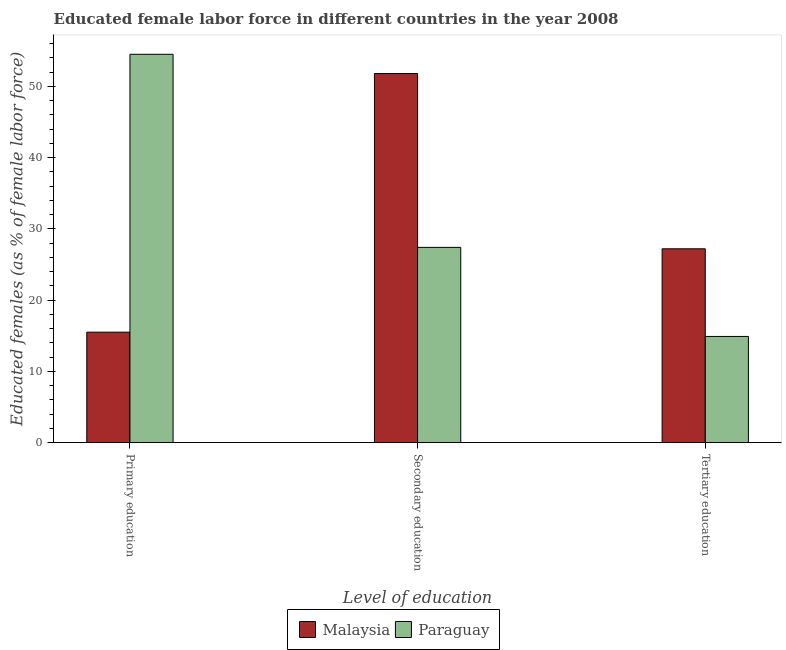How many groups of bars are there?
Your answer should be very brief. 3. Are the number of bars on each tick of the X-axis equal?
Provide a succinct answer. Yes. How many bars are there on the 2nd tick from the left?
Make the answer very short. 2. What is the percentage of female labor force who received tertiary education in Paraguay?
Your answer should be very brief. 14.9. Across all countries, what is the maximum percentage of female labor force who received secondary education?
Your answer should be compact. 51.8. Across all countries, what is the minimum percentage of female labor force who received secondary education?
Provide a succinct answer. 27.4. In which country was the percentage of female labor force who received tertiary education maximum?
Ensure brevity in your answer.  Malaysia. In which country was the percentage of female labor force who received primary education minimum?
Your response must be concise. Malaysia. What is the total percentage of female labor force who received secondary education in the graph?
Your answer should be compact. 79.2. What is the difference between the percentage of female labor force who received primary education in Paraguay and that in Malaysia?
Make the answer very short. 39. What is the difference between the percentage of female labor force who received primary education in Malaysia and the percentage of female labor force who received tertiary education in Paraguay?
Give a very brief answer. 0.6. What is the average percentage of female labor force who received primary education per country?
Your answer should be compact. 35. What is the difference between the percentage of female labor force who received secondary education and percentage of female labor force who received tertiary education in Malaysia?
Offer a very short reply. 24.6. What is the ratio of the percentage of female labor force who received tertiary education in Malaysia to that in Paraguay?
Your answer should be compact. 1.83. What is the difference between the highest and the second highest percentage of female labor force who received tertiary education?
Your response must be concise. 12.3. What is the difference between the highest and the lowest percentage of female labor force who received secondary education?
Offer a terse response. 24.4. Is the sum of the percentage of female labor force who received secondary education in Malaysia and Paraguay greater than the maximum percentage of female labor force who received tertiary education across all countries?
Ensure brevity in your answer.  Yes. What does the 2nd bar from the left in Secondary education represents?
Offer a very short reply. Paraguay. What does the 1st bar from the right in Tertiary education represents?
Offer a very short reply. Paraguay. Are all the bars in the graph horizontal?
Offer a terse response. No. Are the values on the major ticks of Y-axis written in scientific E-notation?
Your answer should be compact. No. How many legend labels are there?
Your answer should be very brief. 2. How are the legend labels stacked?
Keep it short and to the point. Horizontal. What is the title of the graph?
Keep it short and to the point. Educated female labor force in different countries in the year 2008. What is the label or title of the X-axis?
Offer a very short reply. Level of education. What is the label or title of the Y-axis?
Offer a very short reply. Educated females (as % of female labor force). What is the Educated females (as % of female labor force) in Paraguay in Primary education?
Your answer should be compact. 54.5. What is the Educated females (as % of female labor force) of Malaysia in Secondary education?
Make the answer very short. 51.8. What is the Educated females (as % of female labor force) of Paraguay in Secondary education?
Your answer should be very brief. 27.4. What is the Educated females (as % of female labor force) in Malaysia in Tertiary education?
Provide a succinct answer. 27.2. What is the Educated females (as % of female labor force) of Paraguay in Tertiary education?
Your answer should be compact. 14.9. Across all Level of education, what is the maximum Educated females (as % of female labor force) of Malaysia?
Your answer should be compact. 51.8. Across all Level of education, what is the maximum Educated females (as % of female labor force) of Paraguay?
Offer a terse response. 54.5. Across all Level of education, what is the minimum Educated females (as % of female labor force) in Paraguay?
Provide a succinct answer. 14.9. What is the total Educated females (as % of female labor force) in Malaysia in the graph?
Your answer should be very brief. 94.5. What is the total Educated females (as % of female labor force) of Paraguay in the graph?
Keep it short and to the point. 96.8. What is the difference between the Educated females (as % of female labor force) in Malaysia in Primary education and that in Secondary education?
Provide a short and direct response. -36.3. What is the difference between the Educated females (as % of female labor force) in Paraguay in Primary education and that in Secondary education?
Your response must be concise. 27.1. What is the difference between the Educated females (as % of female labor force) of Paraguay in Primary education and that in Tertiary education?
Ensure brevity in your answer.  39.6. What is the difference between the Educated females (as % of female labor force) of Malaysia in Secondary education and that in Tertiary education?
Your answer should be very brief. 24.6. What is the difference between the Educated females (as % of female labor force) in Paraguay in Secondary education and that in Tertiary education?
Give a very brief answer. 12.5. What is the difference between the Educated females (as % of female labor force) in Malaysia in Primary education and the Educated females (as % of female labor force) in Paraguay in Tertiary education?
Offer a terse response. 0.6. What is the difference between the Educated females (as % of female labor force) of Malaysia in Secondary education and the Educated females (as % of female labor force) of Paraguay in Tertiary education?
Your response must be concise. 36.9. What is the average Educated females (as % of female labor force) in Malaysia per Level of education?
Give a very brief answer. 31.5. What is the average Educated females (as % of female labor force) of Paraguay per Level of education?
Make the answer very short. 32.27. What is the difference between the Educated females (as % of female labor force) of Malaysia and Educated females (as % of female labor force) of Paraguay in Primary education?
Your answer should be very brief. -39. What is the difference between the Educated females (as % of female labor force) in Malaysia and Educated females (as % of female labor force) in Paraguay in Secondary education?
Offer a terse response. 24.4. What is the ratio of the Educated females (as % of female labor force) of Malaysia in Primary education to that in Secondary education?
Give a very brief answer. 0.3. What is the ratio of the Educated females (as % of female labor force) in Paraguay in Primary education to that in Secondary education?
Provide a succinct answer. 1.99. What is the ratio of the Educated females (as % of female labor force) in Malaysia in Primary education to that in Tertiary education?
Offer a very short reply. 0.57. What is the ratio of the Educated females (as % of female labor force) of Paraguay in Primary education to that in Tertiary education?
Your answer should be very brief. 3.66. What is the ratio of the Educated females (as % of female labor force) in Malaysia in Secondary education to that in Tertiary education?
Provide a succinct answer. 1.9. What is the ratio of the Educated females (as % of female labor force) in Paraguay in Secondary education to that in Tertiary education?
Your answer should be very brief. 1.84. What is the difference between the highest and the second highest Educated females (as % of female labor force) of Malaysia?
Your answer should be compact. 24.6. What is the difference between the highest and the second highest Educated females (as % of female labor force) of Paraguay?
Give a very brief answer. 27.1. What is the difference between the highest and the lowest Educated females (as % of female labor force) of Malaysia?
Offer a terse response. 36.3. What is the difference between the highest and the lowest Educated females (as % of female labor force) of Paraguay?
Ensure brevity in your answer.  39.6. 